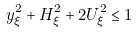<formula> <loc_0><loc_0><loc_500><loc_500>y _ { \xi } ^ { 2 } + H _ { \xi } ^ { 2 } + 2 U _ { \xi } ^ { 2 } \leq 1</formula> 